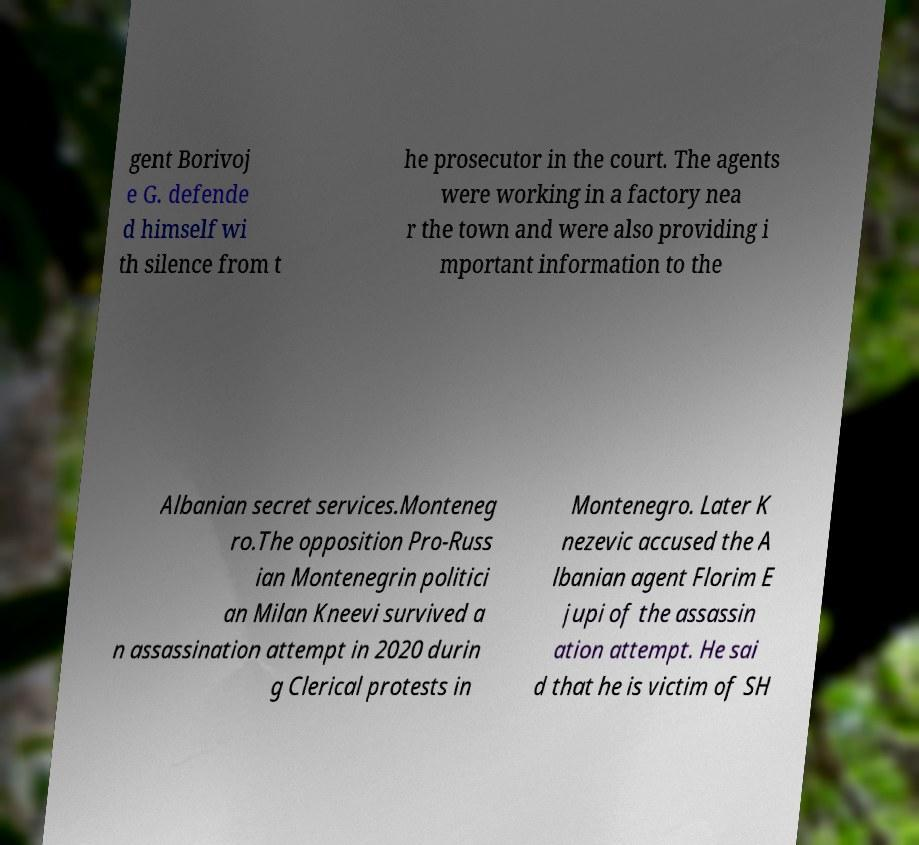Can you accurately transcribe the text from the provided image for me? gent Borivoj e G. defende d himself wi th silence from t he prosecutor in the court. The agents were working in a factory nea r the town and were also providing i mportant information to the Albanian secret services.Monteneg ro.The opposition Pro-Russ ian Montenegrin politici an Milan Kneevi survived a n assassination attempt in 2020 durin g Clerical protests in Montenegro. Later K nezevic accused the A lbanian agent Florim E jupi of the assassin ation attempt. He sai d that he is victim of SH 